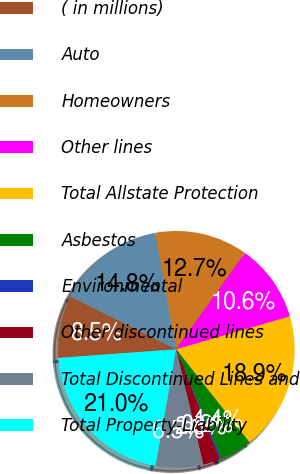Convert chart to OTSL. <chart><loc_0><loc_0><loc_500><loc_500><pie_chart><fcel>( in millions)<fcel>Auto<fcel>Homeowners<fcel>Other lines<fcel>Total Allstate Protection<fcel>Asbestos<fcel>Environmental<fcel>Other discontinued lines<fcel>Total Discontinued Lines and<fcel>Total Property-Liability<nl><fcel>8.55%<fcel>14.79%<fcel>12.71%<fcel>10.63%<fcel>18.87%<fcel>4.4%<fcel>0.24%<fcel>2.32%<fcel>6.48%<fcel>21.02%<nl></chart> 